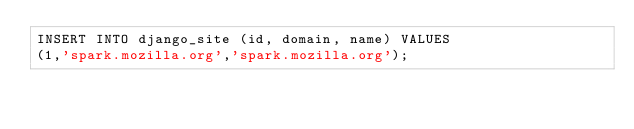<code> <loc_0><loc_0><loc_500><loc_500><_SQL_>INSERT INTO django_site (id, domain, name) VALUES
(1,'spark.mozilla.org','spark.mozilla.org');</code> 